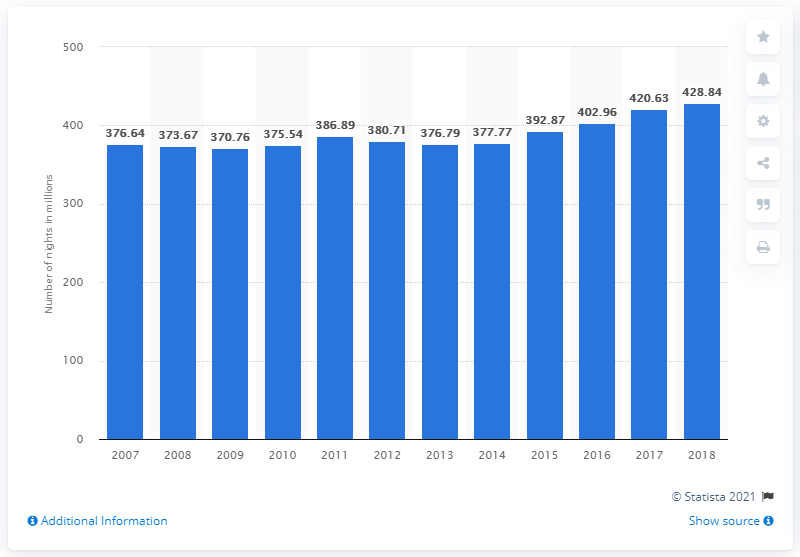Mention a couple of crucial points in this snapshot. Between 2007 and 2018, a total of 428.84 nights were spent at tourist accommodation establishments in Italy. 